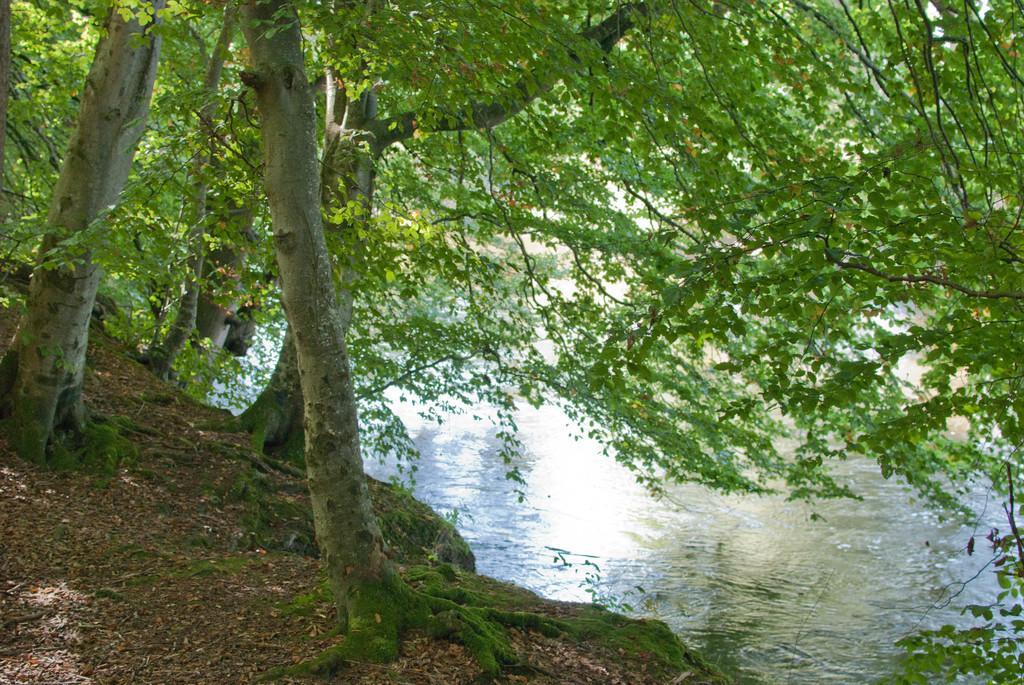What type of natural water body is present in the image? There is a river in the image. What type of vegetation can be seen in the image? There are trees in the image. What type of ground surface is visible in the image? Soil is visible in the image. What type of plant life is present in the image? There are plants in the image. Where is the notebook located in the image? There is no notebook present in the image. What type of clothing is visible on the plants in the image? There is no clothing, including shirts, present in the image. 